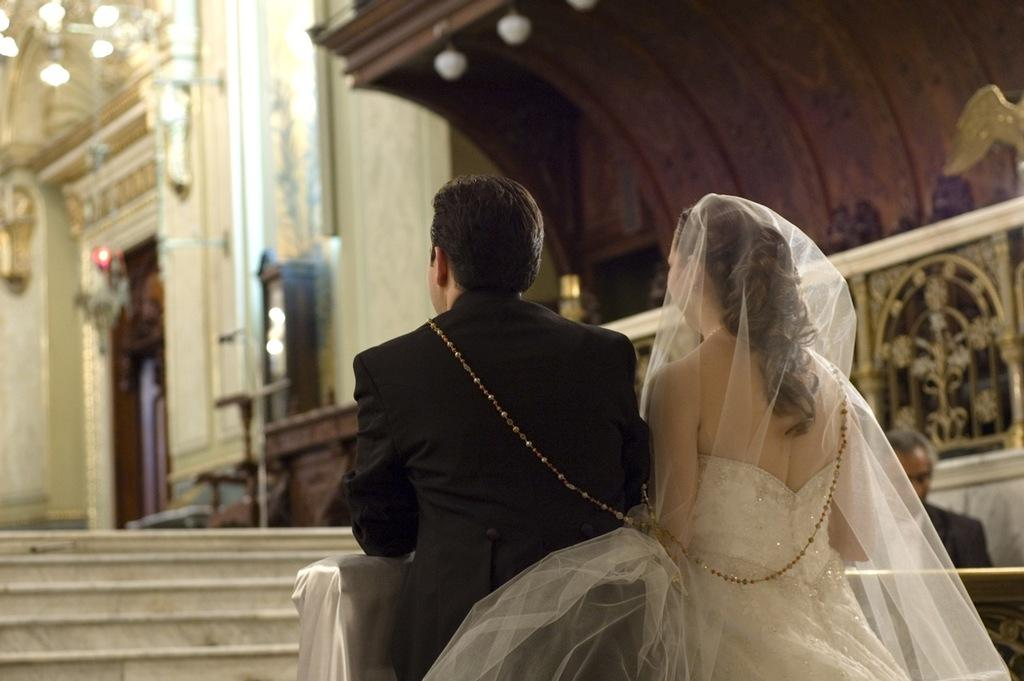What is the lady in the image wearing? The lady in the image is wearing a white gown. Who else is present in the image? There is a guy in the image. What architectural feature can be seen in the image? There is a staircase in the image. What can be seen providing illumination in the image? There are lights in the image. Can you describe any other elements in the image? There are other unspecified things around in the image. What type of substance is being spilled on the sidewalk in the image? There is no sidewalk or substance present in the image. What kind of tank is visible in the image? There is no tank present in the image. 